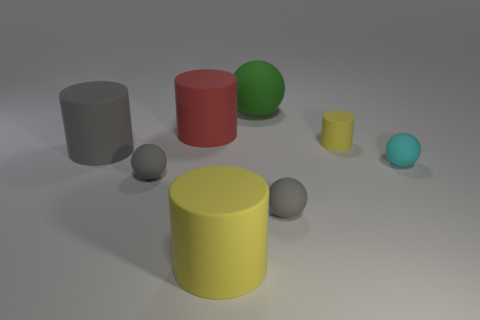Subtract all big cylinders. How many cylinders are left? 1 Subtract all gray cylinders. How many cylinders are left? 3 Subtract all cyan spheres. How many yellow cylinders are left? 2 Add 1 small yellow cylinders. How many objects exist? 9 Subtract all purple cylinders. Subtract all gray balls. How many cylinders are left? 4 Add 1 gray rubber cylinders. How many gray rubber cylinders are left? 2 Add 3 gray rubber cylinders. How many gray rubber cylinders exist? 4 Subtract 0 yellow blocks. How many objects are left? 8 Subtract all yellow things. Subtract all tiny green metallic spheres. How many objects are left? 6 